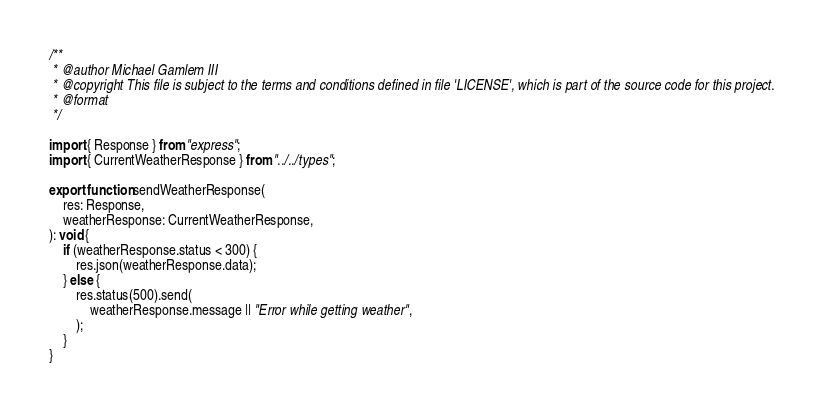Convert code to text. <code><loc_0><loc_0><loc_500><loc_500><_TypeScript_>/**
 * @author Michael Gamlem III
 * @copyright This file is subject to the terms and conditions defined in file 'LICENSE', which is part of the source code for this project.
 * @format
 */

import { Response } from "express";
import { CurrentWeatherResponse } from "../../types";

export function sendWeatherResponse(
	res: Response,
	weatherResponse: CurrentWeatherResponse,
): void {
	if (weatherResponse.status < 300) {
		res.json(weatherResponse.data);
	} else {
		res.status(500).send(
			weatherResponse.message || "Error while getting weather",
		);
	}
}
</code> 